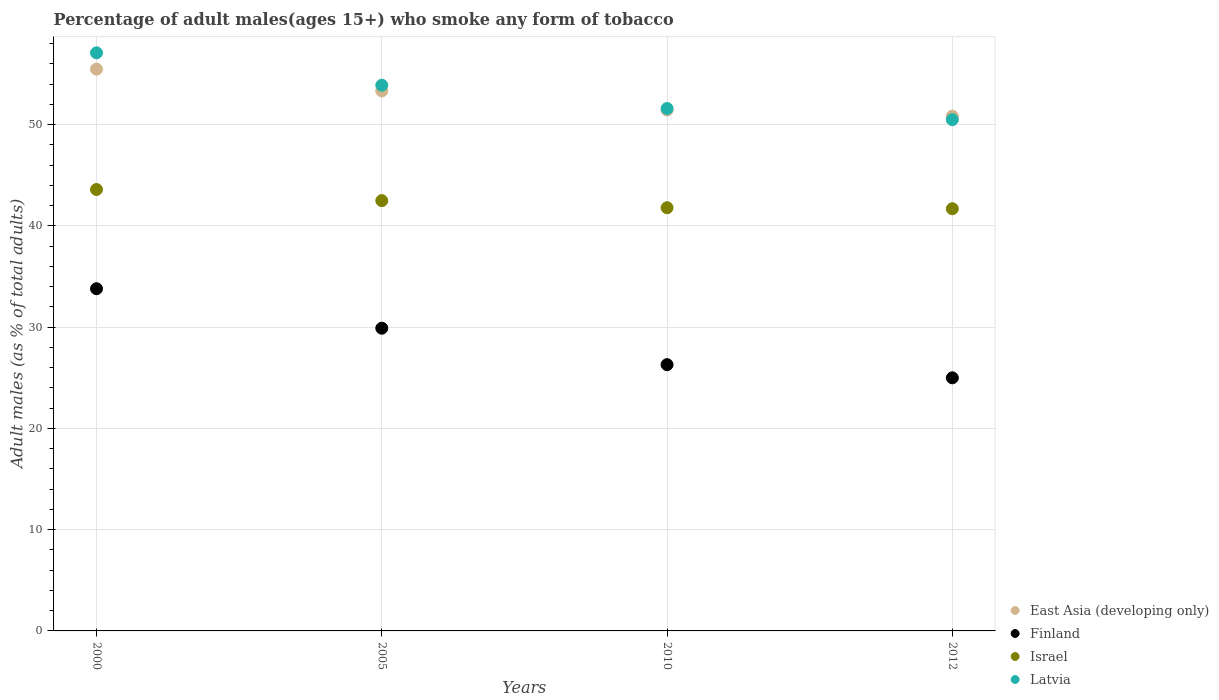How many different coloured dotlines are there?
Offer a very short reply. 4. What is the percentage of adult males who smoke in Israel in 2000?
Your response must be concise. 43.6. Across all years, what is the maximum percentage of adult males who smoke in Israel?
Your answer should be compact. 43.6. In which year was the percentage of adult males who smoke in Latvia maximum?
Your response must be concise. 2000. In which year was the percentage of adult males who smoke in Latvia minimum?
Your answer should be very brief. 2012. What is the total percentage of adult males who smoke in East Asia (developing only) in the graph?
Provide a succinct answer. 211.11. What is the difference between the percentage of adult males who smoke in East Asia (developing only) in 2005 and that in 2010?
Provide a succinct answer. 1.88. What is the difference between the percentage of adult males who smoke in Finland in 2000 and the percentage of adult males who smoke in Israel in 2010?
Keep it short and to the point. -8. What is the average percentage of adult males who smoke in Israel per year?
Offer a very short reply. 42.4. In the year 2010, what is the difference between the percentage of adult males who smoke in Israel and percentage of adult males who smoke in Latvia?
Provide a succinct answer. -9.8. In how many years, is the percentage of adult males who smoke in Israel greater than 48 %?
Your response must be concise. 0. What is the ratio of the percentage of adult males who smoke in Latvia in 2000 to that in 2010?
Provide a succinct answer. 1.11. Is the percentage of adult males who smoke in Israel in 2005 less than that in 2012?
Your response must be concise. No. What is the difference between the highest and the second highest percentage of adult males who smoke in Israel?
Your answer should be compact. 1.1. What is the difference between the highest and the lowest percentage of adult males who smoke in East Asia (developing only)?
Keep it short and to the point. 4.64. In how many years, is the percentage of adult males who smoke in Israel greater than the average percentage of adult males who smoke in Israel taken over all years?
Give a very brief answer. 2. Is the sum of the percentage of adult males who smoke in Latvia in 2000 and 2010 greater than the maximum percentage of adult males who smoke in Israel across all years?
Make the answer very short. Yes. Is it the case that in every year, the sum of the percentage of adult males who smoke in Latvia and percentage of adult males who smoke in East Asia (developing only)  is greater than the sum of percentage of adult males who smoke in Finland and percentage of adult males who smoke in Israel?
Make the answer very short. No. Is it the case that in every year, the sum of the percentage of adult males who smoke in Latvia and percentage of adult males who smoke in Finland  is greater than the percentage of adult males who smoke in Israel?
Give a very brief answer. Yes. Does the percentage of adult males who smoke in East Asia (developing only) monotonically increase over the years?
Offer a terse response. No. Is the percentage of adult males who smoke in Israel strictly less than the percentage of adult males who smoke in Latvia over the years?
Give a very brief answer. Yes. How many dotlines are there?
Make the answer very short. 4. How many years are there in the graph?
Your answer should be very brief. 4. Are the values on the major ticks of Y-axis written in scientific E-notation?
Provide a succinct answer. No. Does the graph contain any zero values?
Your answer should be very brief. No. Does the graph contain grids?
Your answer should be very brief. Yes. Where does the legend appear in the graph?
Your answer should be very brief. Bottom right. How many legend labels are there?
Your answer should be very brief. 4. What is the title of the graph?
Provide a succinct answer. Percentage of adult males(ages 15+) who smoke any form of tobacco. What is the label or title of the X-axis?
Give a very brief answer. Years. What is the label or title of the Y-axis?
Provide a succinct answer. Adult males (as % of total adults). What is the Adult males (as % of total adults) in East Asia (developing only) in 2000?
Give a very brief answer. 55.49. What is the Adult males (as % of total adults) of Finland in 2000?
Provide a succinct answer. 33.8. What is the Adult males (as % of total adults) of Israel in 2000?
Keep it short and to the point. 43.6. What is the Adult males (as % of total adults) in Latvia in 2000?
Provide a succinct answer. 57.1. What is the Adult males (as % of total adults) in East Asia (developing only) in 2005?
Your answer should be very brief. 53.33. What is the Adult males (as % of total adults) of Finland in 2005?
Make the answer very short. 29.9. What is the Adult males (as % of total adults) in Israel in 2005?
Your response must be concise. 42.5. What is the Adult males (as % of total adults) in Latvia in 2005?
Provide a short and direct response. 53.9. What is the Adult males (as % of total adults) in East Asia (developing only) in 2010?
Make the answer very short. 51.45. What is the Adult males (as % of total adults) in Finland in 2010?
Make the answer very short. 26.3. What is the Adult males (as % of total adults) in Israel in 2010?
Give a very brief answer. 41.8. What is the Adult males (as % of total adults) of Latvia in 2010?
Ensure brevity in your answer.  51.6. What is the Adult males (as % of total adults) in East Asia (developing only) in 2012?
Ensure brevity in your answer.  50.84. What is the Adult males (as % of total adults) in Israel in 2012?
Give a very brief answer. 41.7. What is the Adult males (as % of total adults) in Latvia in 2012?
Make the answer very short. 50.5. Across all years, what is the maximum Adult males (as % of total adults) of East Asia (developing only)?
Make the answer very short. 55.49. Across all years, what is the maximum Adult males (as % of total adults) in Finland?
Your answer should be compact. 33.8. Across all years, what is the maximum Adult males (as % of total adults) of Israel?
Your answer should be compact. 43.6. Across all years, what is the maximum Adult males (as % of total adults) of Latvia?
Your response must be concise. 57.1. Across all years, what is the minimum Adult males (as % of total adults) in East Asia (developing only)?
Your answer should be very brief. 50.84. Across all years, what is the minimum Adult males (as % of total adults) of Israel?
Make the answer very short. 41.7. Across all years, what is the minimum Adult males (as % of total adults) in Latvia?
Make the answer very short. 50.5. What is the total Adult males (as % of total adults) of East Asia (developing only) in the graph?
Your response must be concise. 211.11. What is the total Adult males (as % of total adults) in Finland in the graph?
Ensure brevity in your answer.  115. What is the total Adult males (as % of total adults) of Israel in the graph?
Your answer should be compact. 169.6. What is the total Adult males (as % of total adults) of Latvia in the graph?
Provide a succinct answer. 213.1. What is the difference between the Adult males (as % of total adults) of East Asia (developing only) in 2000 and that in 2005?
Your answer should be very brief. 2.15. What is the difference between the Adult males (as % of total adults) in East Asia (developing only) in 2000 and that in 2010?
Make the answer very short. 4.04. What is the difference between the Adult males (as % of total adults) in Israel in 2000 and that in 2010?
Make the answer very short. 1.8. What is the difference between the Adult males (as % of total adults) of East Asia (developing only) in 2000 and that in 2012?
Your answer should be compact. 4.64. What is the difference between the Adult males (as % of total adults) in East Asia (developing only) in 2005 and that in 2010?
Provide a succinct answer. 1.88. What is the difference between the Adult males (as % of total adults) of Finland in 2005 and that in 2010?
Make the answer very short. 3.6. What is the difference between the Adult males (as % of total adults) of Latvia in 2005 and that in 2010?
Your answer should be very brief. 2.3. What is the difference between the Adult males (as % of total adults) in East Asia (developing only) in 2005 and that in 2012?
Provide a succinct answer. 2.49. What is the difference between the Adult males (as % of total adults) in Israel in 2005 and that in 2012?
Keep it short and to the point. 0.8. What is the difference between the Adult males (as % of total adults) in East Asia (developing only) in 2010 and that in 2012?
Ensure brevity in your answer.  0.6. What is the difference between the Adult males (as % of total adults) of East Asia (developing only) in 2000 and the Adult males (as % of total adults) of Finland in 2005?
Ensure brevity in your answer.  25.59. What is the difference between the Adult males (as % of total adults) in East Asia (developing only) in 2000 and the Adult males (as % of total adults) in Israel in 2005?
Provide a short and direct response. 12.99. What is the difference between the Adult males (as % of total adults) in East Asia (developing only) in 2000 and the Adult males (as % of total adults) in Latvia in 2005?
Ensure brevity in your answer.  1.59. What is the difference between the Adult males (as % of total adults) of Finland in 2000 and the Adult males (as % of total adults) of Israel in 2005?
Your answer should be compact. -8.7. What is the difference between the Adult males (as % of total adults) in Finland in 2000 and the Adult males (as % of total adults) in Latvia in 2005?
Keep it short and to the point. -20.1. What is the difference between the Adult males (as % of total adults) in Israel in 2000 and the Adult males (as % of total adults) in Latvia in 2005?
Make the answer very short. -10.3. What is the difference between the Adult males (as % of total adults) in East Asia (developing only) in 2000 and the Adult males (as % of total adults) in Finland in 2010?
Your answer should be compact. 29.19. What is the difference between the Adult males (as % of total adults) of East Asia (developing only) in 2000 and the Adult males (as % of total adults) of Israel in 2010?
Make the answer very short. 13.69. What is the difference between the Adult males (as % of total adults) of East Asia (developing only) in 2000 and the Adult males (as % of total adults) of Latvia in 2010?
Ensure brevity in your answer.  3.89. What is the difference between the Adult males (as % of total adults) in Finland in 2000 and the Adult males (as % of total adults) in Israel in 2010?
Your answer should be compact. -8. What is the difference between the Adult males (as % of total adults) of Finland in 2000 and the Adult males (as % of total adults) of Latvia in 2010?
Your response must be concise. -17.8. What is the difference between the Adult males (as % of total adults) of Israel in 2000 and the Adult males (as % of total adults) of Latvia in 2010?
Provide a short and direct response. -8. What is the difference between the Adult males (as % of total adults) in East Asia (developing only) in 2000 and the Adult males (as % of total adults) in Finland in 2012?
Make the answer very short. 30.49. What is the difference between the Adult males (as % of total adults) of East Asia (developing only) in 2000 and the Adult males (as % of total adults) of Israel in 2012?
Give a very brief answer. 13.79. What is the difference between the Adult males (as % of total adults) of East Asia (developing only) in 2000 and the Adult males (as % of total adults) of Latvia in 2012?
Offer a terse response. 4.99. What is the difference between the Adult males (as % of total adults) of Finland in 2000 and the Adult males (as % of total adults) of Israel in 2012?
Offer a very short reply. -7.9. What is the difference between the Adult males (as % of total adults) in Finland in 2000 and the Adult males (as % of total adults) in Latvia in 2012?
Make the answer very short. -16.7. What is the difference between the Adult males (as % of total adults) of Israel in 2000 and the Adult males (as % of total adults) of Latvia in 2012?
Give a very brief answer. -6.9. What is the difference between the Adult males (as % of total adults) in East Asia (developing only) in 2005 and the Adult males (as % of total adults) in Finland in 2010?
Provide a short and direct response. 27.03. What is the difference between the Adult males (as % of total adults) in East Asia (developing only) in 2005 and the Adult males (as % of total adults) in Israel in 2010?
Offer a terse response. 11.53. What is the difference between the Adult males (as % of total adults) of East Asia (developing only) in 2005 and the Adult males (as % of total adults) of Latvia in 2010?
Keep it short and to the point. 1.73. What is the difference between the Adult males (as % of total adults) in Finland in 2005 and the Adult males (as % of total adults) in Israel in 2010?
Give a very brief answer. -11.9. What is the difference between the Adult males (as % of total adults) in Finland in 2005 and the Adult males (as % of total adults) in Latvia in 2010?
Your answer should be very brief. -21.7. What is the difference between the Adult males (as % of total adults) in East Asia (developing only) in 2005 and the Adult males (as % of total adults) in Finland in 2012?
Your response must be concise. 28.33. What is the difference between the Adult males (as % of total adults) in East Asia (developing only) in 2005 and the Adult males (as % of total adults) in Israel in 2012?
Keep it short and to the point. 11.63. What is the difference between the Adult males (as % of total adults) in East Asia (developing only) in 2005 and the Adult males (as % of total adults) in Latvia in 2012?
Your response must be concise. 2.83. What is the difference between the Adult males (as % of total adults) of Finland in 2005 and the Adult males (as % of total adults) of Latvia in 2012?
Your answer should be compact. -20.6. What is the difference between the Adult males (as % of total adults) of East Asia (developing only) in 2010 and the Adult males (as % of total adults) of Finland in 2012?
Ensure brevity in your answer.  26.45. What is the difference between the Adult males (as % of total adults) in East Asia (developing only) in 2010 and the Adult males (as % of total adults) in Israel in 2012?
Offer a terse response. 9.75. What is the difference between the Adult males (as % of total adults) of East Asia (developing only) in 2010 and the Adult males (as % of total adults) of Latvia in 2012?
Provide a succinct answer. 0.95. What is the difference between the Adult males (as % of total adults) of Finland in 2010 and the Adult males (as % of total adults) of Israel in 2012?
Offer a terse response. -15.4. What is the difference between the Adult males (as % of total adults) of Finland in 2010 and the Adult males (as % of total adults) of Latvia in 2012?
Make the answer very short. -24.2. What is the difference between the Adult males (as % of total adults) of Israel in 2010 and the Adult males (as % of total adults) of Latvia in 2012?
Keep it short and to the point. -8.7. What is the average Adult males (as % of total adults) in East Asia (developing only) per year?
Provide a succinct answer. 52.78. What is the average Adult males (as % of total adults) of Finland per year?
Provide a succinct answer. 28.75. What is the average Adult males (as % of total adults) of Israel per year?
Make the answer very short. 42.4. What is the average Adult males (as % of total adults) in Latvia per year?
Give a very brief answer. 53.27. In the year 2000, what is the difference between the Adult males (as % of total adults) in East Asia (developing only) and Adult males (as % of total adults) in Finland?
Provide a short and direct response. 21.69. In the year 2000, what is the difference between the Adult males (as % of total adults) in East Asia (developing only) and Adult males (as % of total adults) in Israel?
Provide a succinct answer. 11.89. In the year 2000, what is the difference between the Adult males (as % of total adults) in East Asia (developing only) and Adult males (as % of total adults) in Latvia?
Your answer should be very brief. -1.61. In the year 2000, what is the difference between the Adult males (as % of total adults) of Finland and Adult males (as % of total adults) of Latvia?
Provide a succinct answer. -23.3. In the year 2000, what is the difference between the Adult males (as % of total adults) in Israel and Adult males (as % of total adults) in Latvia?
Ensure brevity in your answer.  -13.5. In the year 2005, what is the difference between the Adult males (as % of total adults) in East Asia (developing only) and Adult males (as % of total adults) in Finland?
Keep it short and to the point. 23.43. In the year 2005, what is the difference between the Adult males (as % of total adults) in East Asia (developing only) and Adult males (as % of total adults) in Israel?
Your answer should be compact. 10.83. In the year 2005, what is the difference between the Adult males (as % of total adults) of East Asia (developing only) and Adult males (as % of total adults) of Latvia?
Provide a short and direct response. -0.57. In the year 2005, what is the difference between the Adult males (as % of total adults) in Israel and Adult males (as % of total adults) in Latvia?
Offer a very short reply. -11.4. In the year 2010, what is the difference between the Adult males (as % of total adults) in East Asia (developing only) and Adult males (as % of total adults) in Finland?
Provide a short and direct response. 25.15. In the year 2010, what is the difference between the Adult males (as % of total adults) of East Asia (developing only) and Adult males (as % of total adults) of Israel?
Your answer should be compact. 9.65. In the year 2010, what is the difference between the Adult males (as % of total adults) of East Asia (developing only) and Adult males (as % of total adults) of Latvia?
Make the answer very short. -0.15. In the year 2010, what is the difference between the Adult males (as % of total adults) in Finland and Adult males (as % of total adults) in Israel?
Offer a very short reply. -15.5. In the year 2010, what is the difference between the Adult males (as % of total adults) in Finland and Adult males (as % of total adults) in Latvia?
Ensure brevity in your answer.  -25.3. In the year 2012, what is the difference between the Adult males (as % of total adults) in East Asia (developing only) and Adult males (as % of total adults) in Finland?
Give a very brief answer. 25.84. In the year 2012, what is the difference between the Adult males (as % of total adults) of East Asia (developing only) and Adult males (as % of total adults) of Israel?
Your response must be concise. 9.14. In the year 2012, what is the difference between the Adult males (as % of total adults) in East Asia (developing only) and Adult males (as % of total adults) in Latvia?
Provide a short and direct response. 0.34. In the year 2012, what is the difference between the Adult males (as % of total adults) in Finland and Adult males (as % of total adults) in Israel?
Provide a succinct answer. -16.7. In the year 2012, what is the difference between the Adult males (as % of total adults) in Finland and Adult males (as % of total adults) in Latvia?
Provide a succinct answer. -25.5. In the year 2012, what is the difference between the Adult males (as % of total adults) of Israel and Adult males (as % of total adults) of Latvia?
Ensure brevity in your answer.  -8.8. What is the ratio of the Adult males (as % of total adults) of East Asia (developing only) in 2000 to that in 2005?
Your answer should be very brief. 1.04. What is the ratio of the Adult males (as % of total adults) in Finland in 2000 to that in 2005?
Your answer should be compact. 1.13. What is the ratio of the Adult males (as % of total adults) of Israel in 2000 to that in 2005?
Ensure brevity in your answer.  1.03. What is the ratio of the Adult males (as % of total adults) in Latvia in 2000 to that in 2005?
Ensure brevity in your answer.  1.06. What is the ratio of the Adult males (as % of total adults) of East Asia (developing only) in 2000 to that in 2010?
Offer a terse response. 1.08. What is the ratio of the Adult males (as % of total adults) in Finland in 2000 to that in 2010?
Provide a succinct answer. 1.29. What is the ratio of the Adult males (as % of total adults) of Israel in 2000 to that in 2010?
Offer a terse response. 1.04. What is the ratio of the Adult males (as % of total adults) of Latvia in 2000 to that in 2010?
Provide a succinct answer. 1.11. What is the ratio of the Adult males (as % of total adults) of East Asia (developing only) in 2000 to that in 2012?
Your answer should be compact. 1.09. What is the ratio of the Adult males (as % of total adults) of Finland in 2000 to that in 2012?
Make the answer very short. 1.35. What is the ratio of the Adult males (as % of total adults) in Israel in 2000 to that in 2012?
Keep it short and to the point. 1.05. What is the ratio of the Adult males (as % of total adults) in Latvia in 2000 to that in 2012?
Provide a succinct answer. 1.13. What is the ratio of the Adult males (as % of total adults) in East Asia (developing only) in 2005 to that in 2010?
Your answer should be very brief. 1.04. What is the ratio of the Adult males (as % of total adults) of Finland in 2005 to that in 2010?
Your response must be concise. 1.14. What is the ratio of the Adult males (as % of total adults) in Israel in 2005 to that in 2010?
Ensure brevity in your answer.  1.02. What is the ratio of the Adult males (as % of total adults) of Latvia in 2005 to that in 2010?
Give a very brief answer. 1.04. What is the ratio of the Adult males (as % of total adults) of East Asia (developing only) in 2005 to that in 2012?
Keep it short and to the point. 1.05. What is the ratio of the Adult males (as % of total adults) in Finland in 2005 to that in 2012?
Keep it short and to the point. 1.2. What is the ratio of the Adult males (as % of total adults) in Israel in 2005 to that in 2012?
Make the answer very short. 1.02. What is the ratio of the Adult males (as % of total adults) in Latvia in 2005 to that in 2012?
Offer a terse response. 1.07. What is the ratio of the Adult males (as % of total adults) in East Asia (developing only) in 2010 to that in 2012?
Your answer should be very brief. 1.01. What is the ratio of the Adult males (as % of total adults) of Finland in 2010 to that in 2012?
Offer a very short reply. 1.05. What is the ratio of the Adult males (as % of total adults) of Latvia in 2010 to that in 2012?
Ensure brevity in your answer.  1.02. What is the difference between the highest and the second highest Adult males (as % of total adults) in East Asia (developing only)?
Provide a succinct answer. 2.15. What is the difference between the highest and the second highest Adult males (as % of total adults) of Finland?
Ensure brevity in your answer.  3.9. What is the difference between the highest and the second highest Adult males (as % of total adults) of Latvia?
Your response must be concise. 3.2. What is the difference between the highest and the lowest Adult males (as % of total adults) of East Asia (developing only)?
Give a very brief answer. 4.64. What is the difference between the highest and the lowest Adult males (as % of total adults) in Finland?
Provide a short and direct response. 8.8. 